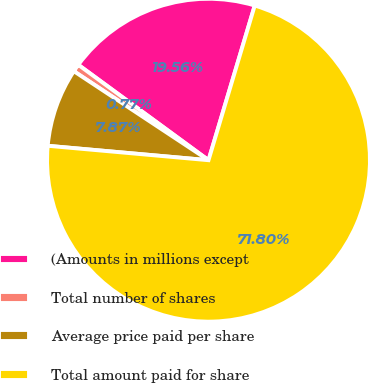<chart> <loc_0><loc_0><loc_500><loc_500><pie_chart><fcel>(Amounts in millions except<fcel>Total number of shares<fcel>Average price paid per share<fcel>Total amount paid for share<nl><fcel>19.56%<fcel>0.77%<fcel>7.87%<fcel>71.8%<nl></chart> 